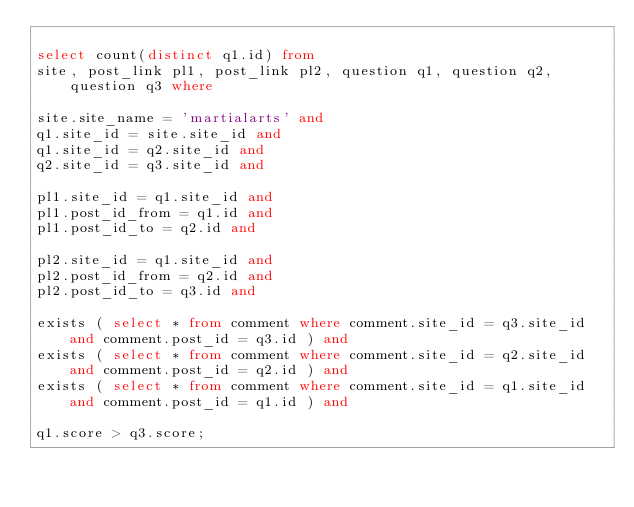Convert code to text. <code><loc_0><loc_0><loc_500><loc_500><_SQL_>
select count(distinct q1.id) from
site, post_link pl1, post_link pl2, question q1, question q2, question q3 where

site.site_name = 'martialarts' and
q1.site_id = site.site_id and
q1.site_id = q2.site_id and
q2.site_id = q3.site_id and

pl1.site_id = q1.site_id and
pl1.post_id_from = q1.id and
pl1.post_id_to = q2.id and

pl2.site_id = q1.site_id and
pl2.post_id_from = q2.id and
pl2.post_id_to = q3.id and

exists ( select * from comment where comment.site_id = q3.site_id and comment.post_id = q3.id ) and
exists ( select * from comment where comment.site_id = q2.site_id and comment.post_id = q2.id ) and
exists ( select * from comment where comment.site_id = q1.site_id and comment.post_id = q1.id ) and

q1.score > q3.score;
</code> 